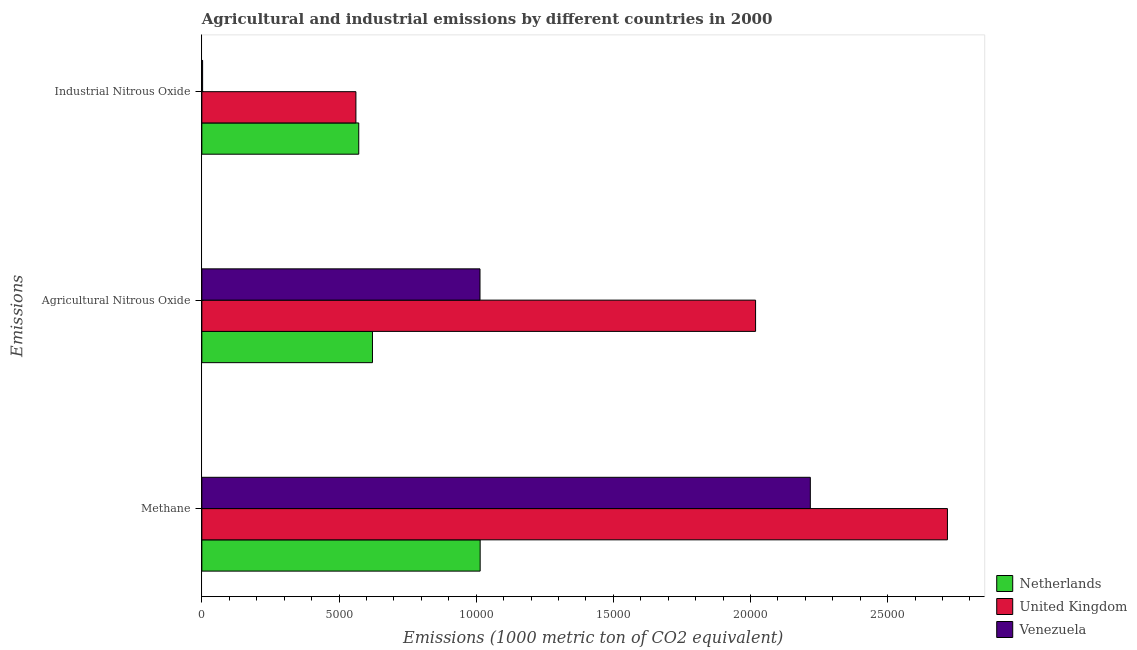How many different coloured bars are there?
Offer a very short reply. 3. How many groups of bars are there?
Keep it short and to the point. 3. Are the number of bars on each tick of the Y-axis equal?
Give a very brief answer. Yes. How many bars are there on the 3rd tick from the top?
Your response must be concise. 3. How many bars are there on the 1st tick from the bottom?
Provide a succinct answer. 3. What is the label of the 1st group of bars from the top?
Provide a short and direct response. Industrial Nitrous Oxide. What is the amount of agricultural nitrous oxide emissions in Netherlands?
Offer a very short reply. 6219.5. Across all countries, what is the maximum amount of agricultural nitrous oxide emissions?
Offer a very short reply. 2.02e+04. Across all countries, what is the minimum amount of agricultural nitrous oxide emissions?
Give a very brief answer. 6219.5. In which country was the amount of agricultural nitrous oxide emissions maximum?
Provide a short and direct response. United Kingdom. What is the total amount of methane emissions in the graph?
Ensure brevity in your answer.  5.95e+04. What is the difference between the amount of agricultural nitrous oxide emissions in United Kingdom and that in Netherlands?
Your response must be concise. 1.40e+04. What is the difference between the amount of agricultural nitrous oxide emissions in Venezuela and the amount of methane emissions in Netherlands?
Your answer should be compact. -5.2. What is the average amount of industrial nitrous oxide emissions per country?
Provide a succinct answer. 3787.8. What is the difference between the amount of agricultural nitrous oxide emissions and amount of methane emissions in Venezuela?
Provide a succinct answer. -1.20e+04. In how many countries, is the amount of methane emissions greater than 7000 metric ton?
Offer a terse response. 3. What is the ratio of the amount of industrial nitrous oxide emissions in Venezuela to that in Netherlands?
Provide a succinct answer. 0. Is the amount of agricultural nitrous oxide emissions in Venezuela less than that in Netherlands?
Ensure brevity in your answer.  No. What is the difference between the highest and the second highest amount of agricultural nitrous oxide emissions?
Keep it short and to the point. 1.00e+04. What is the difference between the highest and the lowest amount of methane emissions?
Offer a terse response. 1.70e+04. In how many countries, is the amount of agricultural nitrous oxide emissions greater than the average amount of agricultural nitrous oxide emissions taken over all countries?
Provide a short and direct response. 1. What does the 3rd bar from the bottom in Agricultural Nitrous Oxide represents?
Your answer should be compact. Venezuela. How many bars are there?
Make the answer very short. 9. How many countries are there in the graph?
Make the answer very short. 3. What is the difference between two consecutive major ticks on the X-axis?
Ensure brevity in your answer.  5000. Does the graph contain any zero values?
Keep it short and to the point. No. Where does the legend appear in the graph?
Make the answer very short. Bottom right. What is the title of the graph?
Give a very brief answer. Agricultural and industrial emissions by different countries in 2000. Does "Croatia" appear as one of the legend labels in the graph?
Give a very brief answer. No. What is the label or title of the X-axis?
Provide a succinct answer. Emissions (1000 metric ton of CO2 equivalent). What is the label or title of the Y-axis?
Offer a very short reply. Emissions. What is the Emissions (1000 metric ton of CO2 equivalent) of Netherlands in Methane?
Your response must be concise. 1.01e+04. What is the Emissions (1000 metric ton of CO2 equivalent) of United Kingdom in Methane?
Your answer should be compact. 2.72e+04. What is the Emissions (1000 metric ton of CO2 equivalent) in Venezuela in Methane?
Offer a very short reply. 2.22e+04. What is the Emissions (1000 metric ton of CO2 equivalent) of Netherlands in Agricultural Nitrous Oxide?
Your answer should be very brief. 6219.5. What is the Emissions (1000 metric ton of CO2 equivalent) of United Kingdom in Agricultural Nitrous Oxide?
Your answer should be compact. 2.02e+04. What is the Emissions (1000 metric ton of CO2 equivalent) of Venezuela in Agricultural Nitrous Oxide?
Your response must be concise. 1.01e+04. What is the Emissions (1000 metric ton of CO2 equivalent) of Netherlands in Industrial Nitrous Oxide?
Provide a succinct answer. 5719.5. What is the Emissions (1000 metric ton of CO2 equivalent) in United Kingdom in Industrial Nitrous Oxide?
Keep it short and to the point. 5616. What is the Emissions (1000 metric ton of CO2 equivalent) in Venezuela in Industrial Nitrous Oxide?
Keep it short and to the point. 27.9. Across all Emissions, what is the maximum Emissions (1000 metric ton of CO2 equivalent) of Netherlands?
Your response must be concise. 1.01e+04. Across all Emissions, what is the maximum Emissions (1000 metric ton of CO2 equivalent) in United Kingdom?
Make the answer very short. 2.72e+04. Across all Emissions, what is the maximum Emissions (1000 metric ton of CO2 equivalent) of Venezuela?
Provide a short and direct response. 2.22e+04. Across all Emissions, what is the minimum Emissions (1000 metric ton of CO2 equivalent) in Netherlands?
Your answer should be very brief. 5719.5. Across all Emissions, what is the minimum Emissions (1000 metric ton of CO2 equivalent) of United Kingdom?
Make the answer very short. 5616. Across all Emissions, what is the minimum Emissions (1000 metric ton of CO2 equivalent) in Venezuela?
Offer a terse response. 27.9. What is the total Emissions (1000 metric ton of CO2 equivalent) of Netherlands in the graph?
Offer a very short reply. 2.21e+04. What is the total Emissions (1000 metric ton of CO2 equivalent) in United Kingdom in the graph?
Give a very brief answer. 5.30e+04. What is the total Emissions (1000 metric ton of CO2 equivalent) in Venezuela in the graph?
Offer a terse response. 3.23e+04. What is the difference between the Emissions (1000 metric ton of CO2 equivalent) in Netherlands in Methane and that in Agricultural Nitrous Oxide?
Provide a succinct answer. 3925.3. What is the difference between the Emissions (1000 metric ton of CO2 equivalent) in United Kingdom in Methane and that in Agricultural Nitrous Oxide?
Keep it short and to the point. 6993.2. What is the difference between the Emissions (1000 metric ton of CO2 equivalent) in Venezuela in Methane and that in Agricultural Nitrous Oxide?
Your response must be concise. 1.20e+04. What is the difference between the Emissions (1000 metric ton of CO2 equivalent) of Netherlands in Methane and that in Industrial Nitrous Oxide?
Provide a short and direct response. 4425.3. What is the difference between the Emissions (1000 metric ton of CO2 equivalent) in United Kingdom in Methane and that in Industrial Nitrous Oxide?
Make the answer very short. 2.16e+04. What is the difference between the Emissions (1000 metric ton of CO2 equivalent) in Venezuela in Methane and that in Industrial Nitrous Oxide?
Make the answer very short. 2.22e+04. What is the difference between the Emissions (1000 metric ton of CO2 equivalent) of United Kingdom in Agricultural Nitrous Oxide and that in Industrial Nitrous Oxide?
Your response must be concise. 1.46e+04. What is the difference between the Emissions (1000 metric ton of CO2 equivalent) of Venezuela in Agricultural Nitrous Oxide and that in Industrial Nitrous Oxide?
Make the answer very short. 1.01e+04. What is the difference between the Emissions (1000 metric ton of CO2 equivalent) in Netherlands in Methane and the Emissions (1000 metric ton of CO2 equivalent) in United Kingdom in Agricultural Nitrous Oxide?
Offer a very short reply. -1.00e+04. What is the difference between the Emissions (1000 metric ton of CO2 equivalent) of Netherlands in Methane and the Emissions (1000 metric ton of CO2 equivalent) of Venezuela in Agricultural Nitrous Oxide?
Provide a short and direct response. 5.2. What is the difference between the Emissions (1000 metric ton of CO2 equivalent) in United Kingdom in Methane and the Emissions (1000 metric ton of CO2 equivalent) in Venezuela in Agricultural Nitrous Oxide?
Your answer should be very brief. 1.70e+04. What is the difference between the Emissions (1000 metric ton of CO2 equivalent) in Netherlands in Methane and the Emissions (1000 metric ton of CO2 equivalent) in United Kingdom in Industrial Nitrous Oxide?
Keep it short and to the point. 4528.8. What is the difference between the Emissions (1000 metric ton of CO2 equivalent) in Netherlands in Methane and the Emissions (1000 metric ton of CO2 equivalent) in Venezuela in Industrial Nitrous Oxide?
Offer a very short reply. 1.01e+04. What is the difference between the Emissions (1000 metric ton of CO2 equivalent) in United Kingdom in Methane and the Emissions (1000 metric ton of CO2 equivalent) in Venezuela in Industrial Nitrous Oxide?
Your answer should be compact. 2.72e+04. What is the difference between the Emissions (1000 metric ton of CO2 equivalent) of Netherlands in Agricultural Nitrous Oxide and the Emissions (1000 metric ton of CO2 equivalent) of United Kingdom in Industrial Nitrous Oxide?
Offer a terse response. 603.5. What is the difference between the Emissions (1000 metric ton of CO2 equivalent) in Netherlands in Agricultural Nitrous Oxide and the Emissions (1000 metric ton of CO2 equivalent) in Venezuela in Industrial Nitrous Oxide?
Offer a terse response. 6191.6. What is the difference between the Emissions (1000 metric ton of CO2 equivalent) in United Kingdom in Agricultural Nitrous Oxide and the Emissions (1000 metric ton of CO2 equivalent) in Venezuela in Industrial Nitrous Oxide?
Offer a very short reply. 2.02e+04. What is the average Emissions (1000 metric ton of CO2 equivalent) in Netherlands per Emissions?
Make the answer very short. 7361.27. What is the average Emissions (1000 metric ton of CO2 equivalent) of United Kingdom per Emissions?
Give a very brief answer. 1.77e+04. What is the average Emissions (1000 metric ton of CO2 equivalent) in Venezuela per Emissions?
Your response must be concise. 1.08e+04. What is the difference between the Emissions (1000 metric ton of CO2 equivalent) of Netherlands and Emissions (1000 metric ton of CO2 equivalent) of United Kingdom in Methane?
Offer a terse response. -1.70e+04. What is the difference between the Emissions (1000 metric ton of CO2 equivalent) in Netherlands and Emissions (1000 metric ton of CO2 equivalent) in Venezuela in Methane?
Offer a very short reply. -1.20e+04. What is the difference between the Emissions (1000 metric ton of CO2 equivalent) in United Kingdom and Emissions (1000 metric ton of CO2 equivalent) in Venezuela in Methane?
Make the answer very short. 4997.7. What is the difference between the Emissions (1000 metric ton of CO2 equivalent) in Netherlands and Emissions (1000 metric ton of CO2 equivalent) in United Kingdom in Agricultural Nitrous Oxide?
Make the answer very short. -1.40e+04. What is the difference between the Emissions (1000 metric ton of CO2 equivalent) of Netherlands and Emissions (1000 metric ton of CO2 equivalent) of Venezuela in Agricultural Nitrous Oxide?
Your answer should be compact. -3920.1. What is the difference between the Emissions (1000 metric ton of CO2 equivalent) in United Kingdom and Emissions (1000 metric ton of CO2 equivalent) in Venezuela in Agricultural Nitrous Oxide?
Your answer should be compact. 1.00e+04. What is the difference between the Emissions (1000 metric ton of CO2 equivalent) in Netherlands and Emissions (1000 metric ton of CO2 equivalent) in United Kingdom in Industrial Nitrous Oxide?
Your answer should be very brief. 103.5. What is the difference between the Emissions (1000 metric ton of CO2 equivalent) in Netherlands and Emissions (1000 metric ton of CO2 equivalent) in Venezuela in Industrial Nitrous Oxide?
Keep it short and to the point. 5691.6. What is the difference between the Emissions (1000 metric ton of CO2 equivalent) of United Kingdom and Emissions (1000 metric ton of CO2 equivalent) of Venezuela in Industrial Nitrous Oxide?
Your answer should be compact. 5588.1. What is the ratio of the Emissions (1000 metric ton of CO2 equivalent) in Netherlands in Methane to that in Agricultural Nitrous Oxide?
Offer a terse response. 1.63. What is the ratio of the Emissions (1000 metric ton of CO2 equivalent) of United Kingdom in Methane to that in Agricultural Nitrous Oxide?
Your answer should be very brief. 1.35. What is the ratio of the Emissions (1000 metric ton of CO2 equivalent) of Venezuela in Methane to that in Agricultural Nitrous Oxide?
Your answer should be very brief. 2.19. What is the ratio of the Emissions (1000 metric ton of CO2 equivalent) in Netherlands in Methane to that in Industrial Nitrous Oxide?
Make the answer very short. 1.77. What is the ratio of the Emissions (1000 metric ton of CO2 equivalent) in United Kingdom in Methane to that in Industrial Nitrous Oxide?
Provide a short and direct response. 4.84. What is the ratio of the Emissions (1000 metric ton of CO2 equivalent) in Venezuela in Methane to that in Industrial Nitrous Oxide?
Your answer should be very brief. 795. What is the ratio of the Emissions (1000 metric ton of CO2 equivalent) of Netherlands in Agricultural Nitrous Oxide to that in Industrial Nitrous Oxide?
Provide a succinct answer. 1.09. What is the ratio of the Emissions (1000 metric ton of CO2 equivalent) of United Kingdom in Agricultural Nitrous Oxide to that in Industrial Nitrous Oxide?
Offer a terse response. 3.59. What is the ratio of the Emissions (1000 metric ton of CO2 equivalent) of Venezuela in Agricultural Nitrous Oxide to that in Industrial Nitrous Oxide?
Make the answer very short. 363.43. What is the difference between the highest and the second highest Emissions (1000 metric ton of CO2 equivalent) of Netherlands?
Keep it short and to the point. 3925.3. What is the difference between the highest and the second highest Emissions (1000 metric ton of CO2 equivalent) of United Kingdom?
Provide a succinct answer. 6993.2. What is the difference between the highest and the second highest Emissions (1000 metric ton of CO2 equivalent) of Venezuela?
Make the answer very short. 1.20e+04. What is the difference between the highest and the lowest Emissions (1000 metric ton of CO2 equivalent) in Netherlands?
Keep it short and to the point. 4425.3. What is the difference between the highest and the lowest Emissions (1000 metric ton of CO2 equivalent) in United Kingdom?
Offer a terse response. 2.16e+04. What is the difference between the highest and the lowest Emissions (1000 metric ton of CO2 equivalent) of Venezuela?
Your answer should be compact. 2.22e+04. 